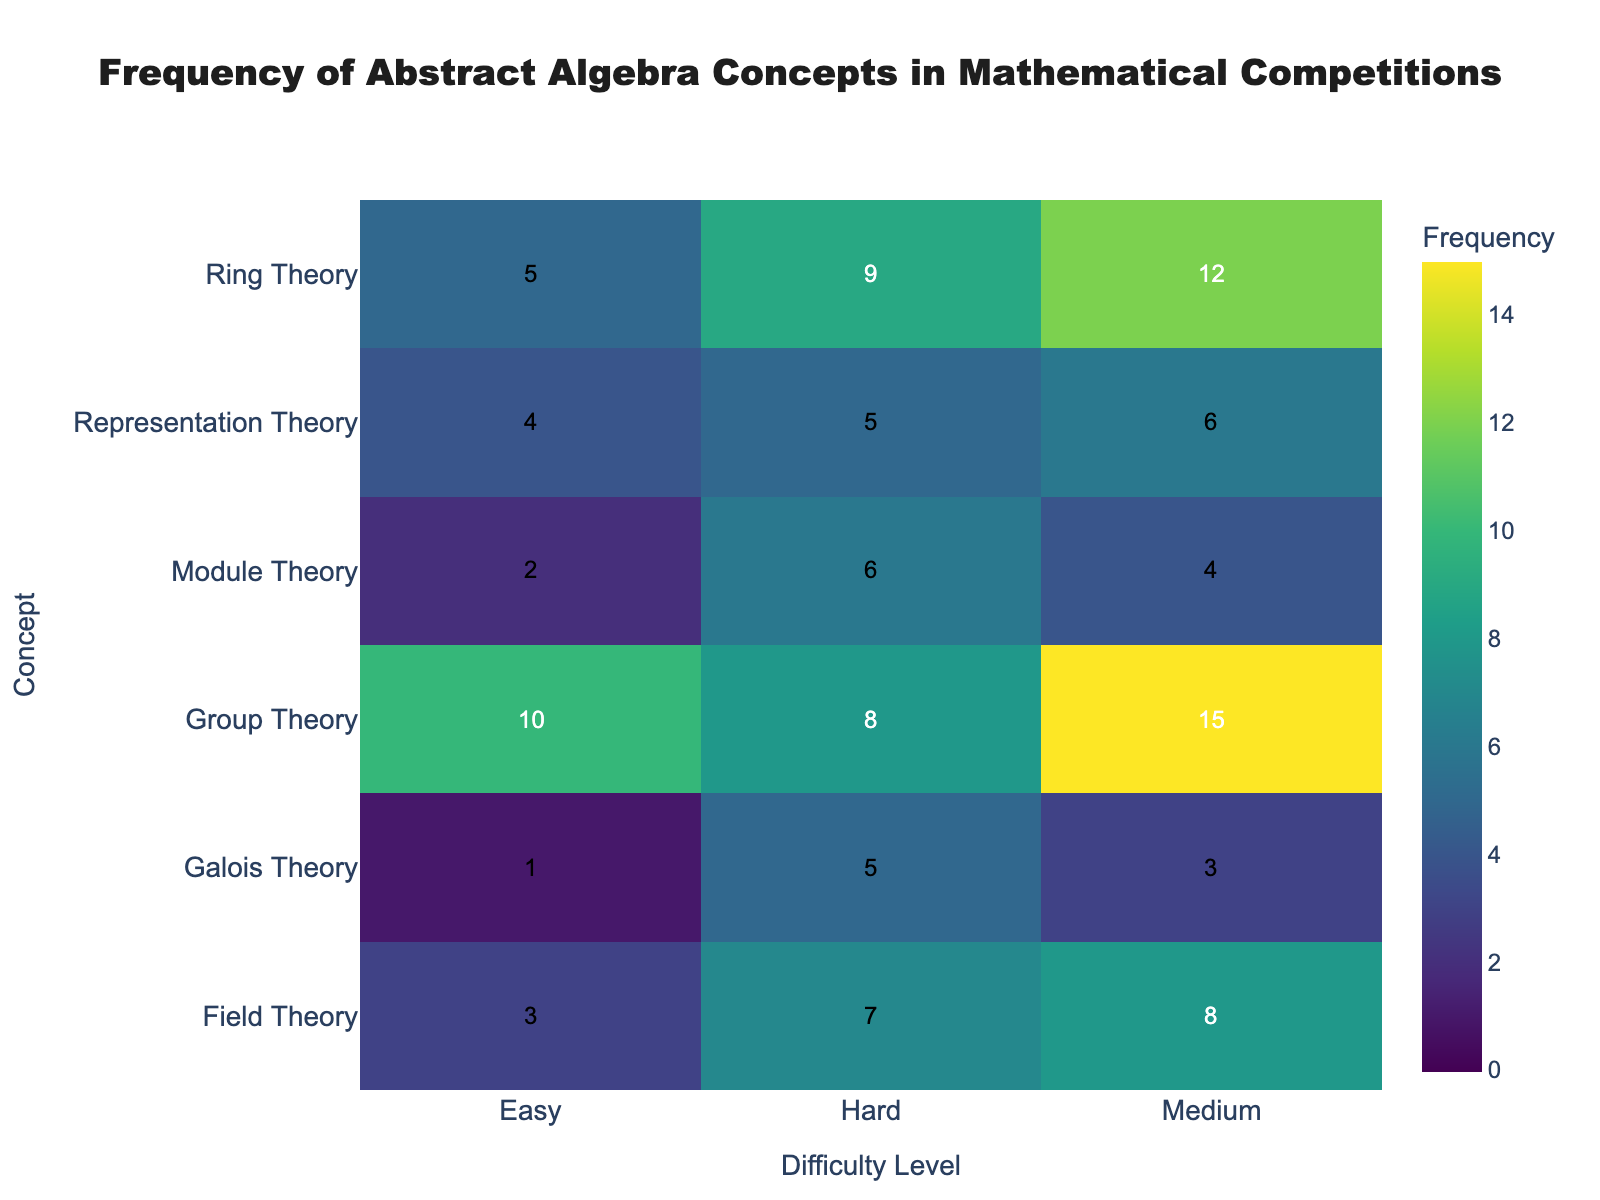What's the title of the heatmap? The title of the heatmap can be found at the top and it provides a brief summary of what the figure represents. In this case, it's "Frequency of Abstract Algebra Concepts in Mathematical Competitions".
Answer: Frequency of Abstract Algebra Concepts in Mathematical Competitions What does the colorbar represent? The colorbar typically provides a scale for understanding the values being represented by colors in the heatmap. Here, it indicates that the colors represent the frequency of concepts.
Answer: Frequency Which concept has the highest frequency in the medium difficulty level? By observing the heatmap, you can look for the highest value in the medium difficulty column. The highest frequency is for Group Theory with a value of 15.
Answer: Group Theory Which concept has the lowest overall frequency across all difficulty levels? To determine this, we need to look at the numbers across all difficulty levels for each concept and identify the smallest value. Galois Theory has the lowest individual frequency of 1 in the easy difficulty level.
Answer: Galois Theory What is the difference in frequency between Ring Theory and Module Theory at the medium difficulty level? Find the frequency values for both concepts at the medium difficulty level and subtract the smaller number from the larger. Ring Theory has a frequency of 12, and Module Theory has 4. The difference is 12 - 4.
Answer: 8 Which difficulty level has the highest overall frequency for Group Theory? Look at the three frequencies listed for Group Theory and find the largest number. Group Theory has 10 (Easy), 15 (Medium), and 8 (Hard). The highest value is 15, which is at the medium difficulty level.
Answer: Medium Are there more concepts with higher frequencies in easy or hard difficulty levels? Sum up the frequencies in the easy and hard difficulty levels for a comparison. Easy level sum: 10+5+3+1+2+4 = 25. Hard level sum: 8+9+7+5+6+5 = 40. Clearly, there are more concepts with higher frequencies in the hard difficulty level.
Answer: Hard What is the average frequency of Field Theory across all difficulty levels? Add up the frequencies of Field Theory across all difficulty levels and divide by the number of levels. (3 + 8 + 7) / 3 = 18 / 3.
Answer: 6 Which concept has the largest increase in frequency from Easy to Medium difficulty level? Calculate the difference for each concept between Easy and Medium levels and look for the largest positive change. Differences: Group Theory (15-10=5), Ring Theory (12-5=7), Field Theory (8-3=5), Galois Theory (3-1=2), Module Theory (4-2=2), Representation Theory (6-4=2). The largest increase is 7 for Ring Theory.
Answer: Ring Theory 